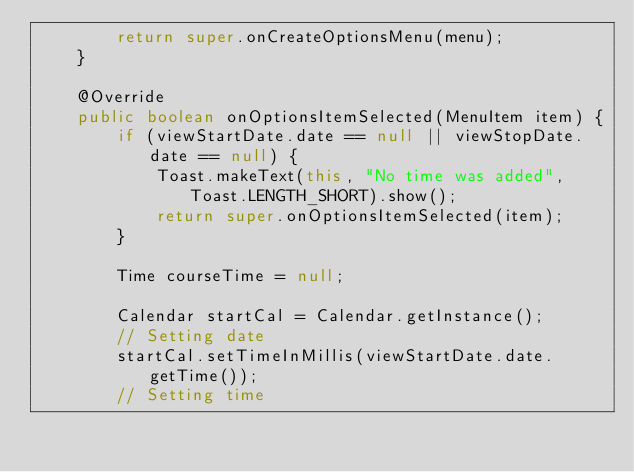<code> <loc_0><loc_0><loc_500><loc_500><_Java_>        return super.onCreateOptionsMenu(menu);
    }

    @Override
    public boolean onOptionsItemSelected(MenuItem item) {
        if (viewStartDate.date == null || viewStopDate.date == null) {
            Toast.makeText(this, "No time was added", Toast.LENGTH_SHORT).show();
            return super.onOptionsItemSelected(item);
        }

        Time courseTime = null;

        Calendar startCal = Calendar.getInstance();
        // Setting date
        startCal.setTimeInMillis(viewStartDate.date.getTime());
        // Setting time</code> 